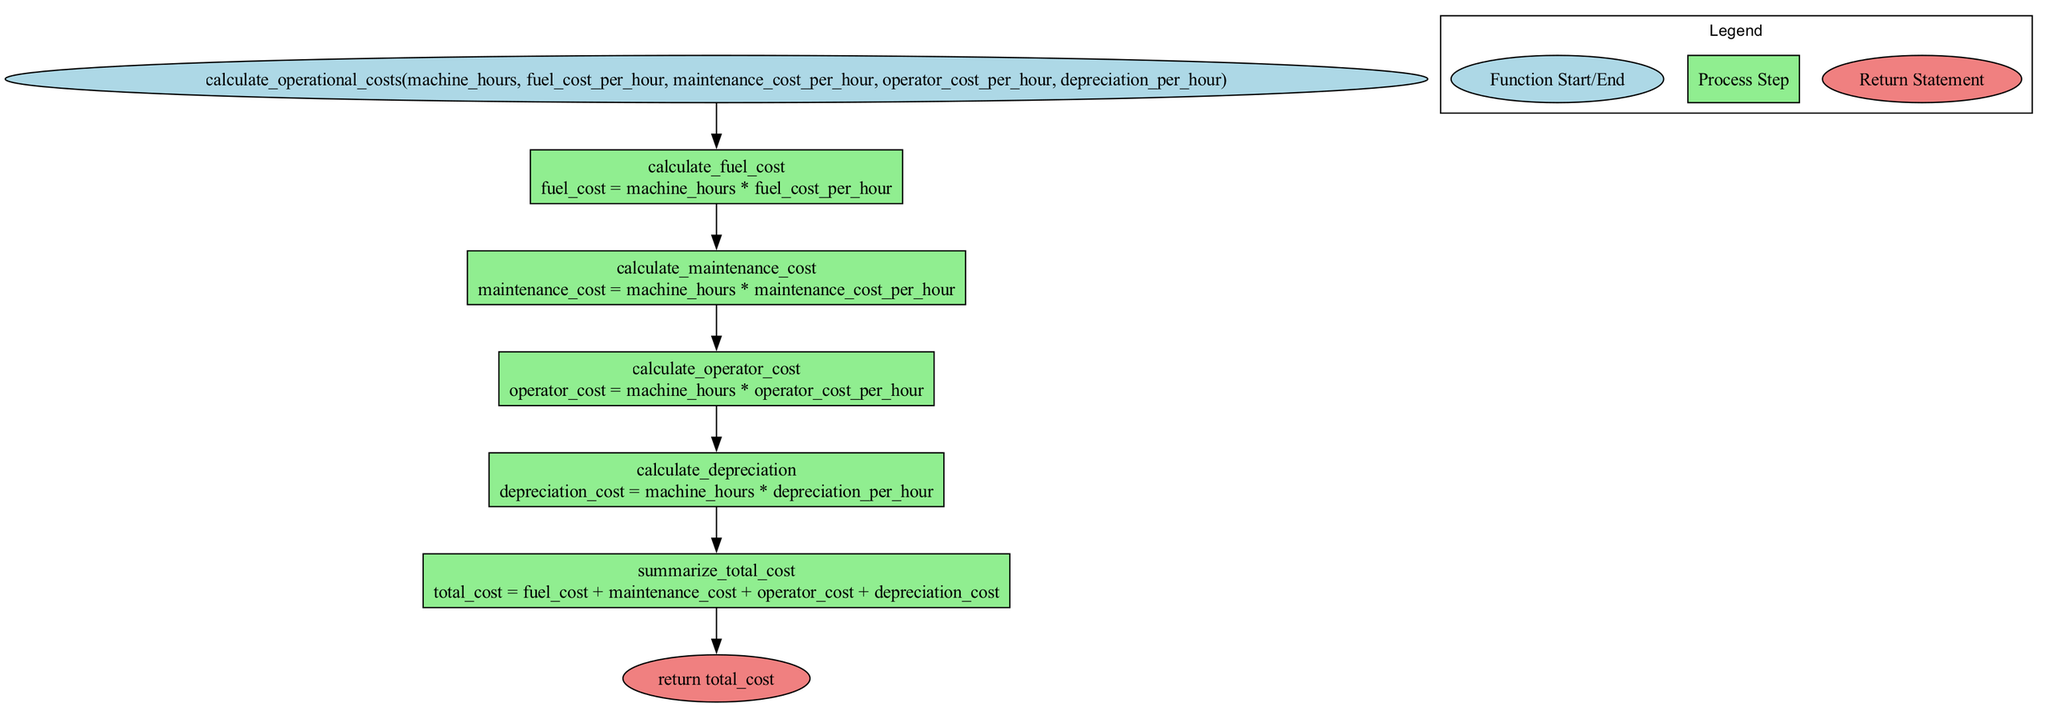What is the name of the function in the diagram? The diagram specifies the function name at the start, which is shown in a distinct ellipse shape filled with light blue color. The name is "calculate_operational_costs."
Answer: calculate operational costs How many parameters does the function take? The diagram lists five parameters in the ellipse at the start of the flowchart. They are separated by commas.
Answer: five What is calculated first in the flowchart? The first step in the flowchart is represented by "calculate_fuel_cost," which is the first process after the function start. This is where the fuel cost is computed.
Answer: calculate fuel cost What is the output variable of the last process step? The last step is "summarize_total_cost," and its output variable is "total_cost," which summarizes all previous calculations. This is indicated in the box at that step.
Answer: total cost What is the relationship between the "calculate_operator_cost" step and the "summarize_total_cost" step? The "calculate_operator_cost" step feeds into the "summarize_total_cost" step directly, as it's one of the components summed to compute the total cost. The edges between these process boxes in the flowchart indicate this flow.
Answer: directly connected How is the total cost calculated? The total cost is computed by adding all individual costs: fuel cost, maintenance cost, operator cost, and depreciation cost. This is described in the "summarize_total_cost" step in the flowchart.
Answer: by summing individual costs What does the return statement indicate in the diagram? The return statement at the end of the flowchart shows what the function will output after performing all calculations. It indicates that the final output is the total cost, signifying the end of the function's computation.
Answer: total cost What color represents the process steps in the flowchart? The process steps in the flowchart are represented by light green boxes. This color differentiation helps to identify the action items clearly in the diagram.
Answer: light green What is the shape of the nodes representing the start and end of the function? The start and end of the function are represented by nodes in the shape of ellipses. This allows for quick identification of the function's initiation and termination points.
Answer: ellipse 